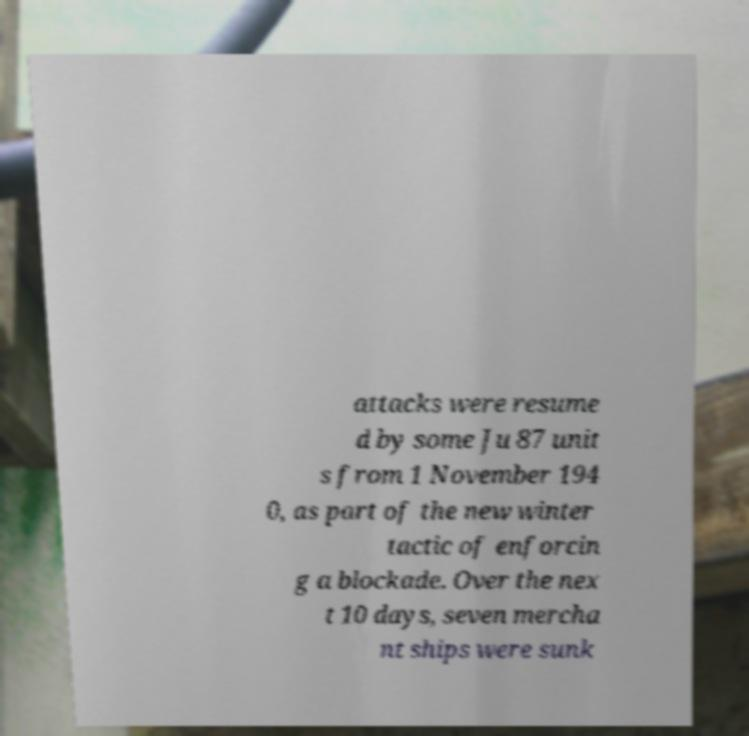Could you extract and type out the text from this image? attacks were resume d by some Ju 87 unit s from 1 November 194 0, as part of the new winter tactic of enforcin g a blockade. Over the nex t 10 days, seven mercha nt ships were sunk 